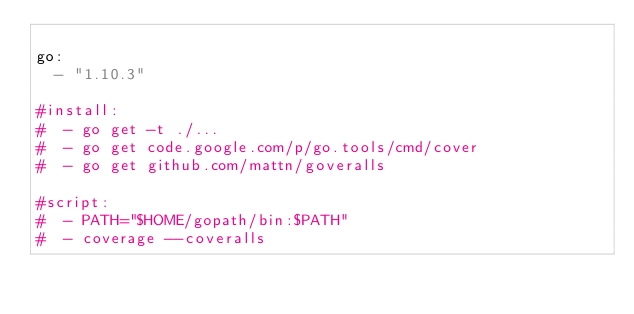Convert code to text. <code><loc_0><loc_0><loc_500><loc_500><_YAML_>
go:
  - "1.10.3"

#install:
#  - go get -t ./...
#  - go get code.google.com/p/go.tools/cmd/cover
#  - go get github.com/mattn/goveralls

#script:
#  - PATH="$HOME/gopath/bin:$PATH"
#  - coverage --coveralls
</code> 